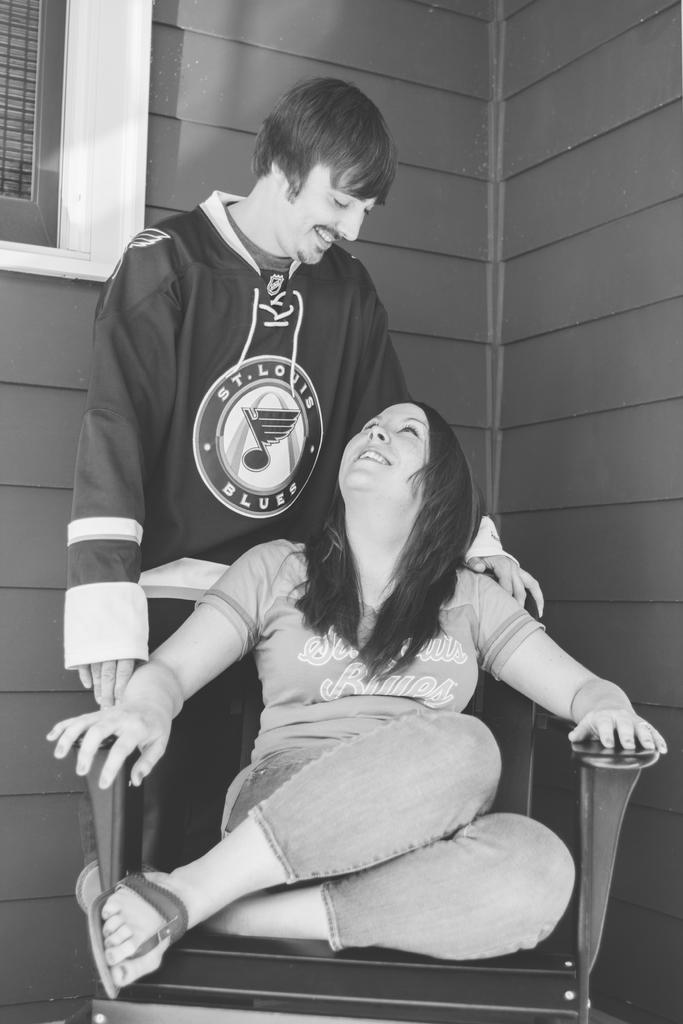<image>
Provide a brief description of the given image. A man stands behind a girl wearing a St Louis Blues jacket 